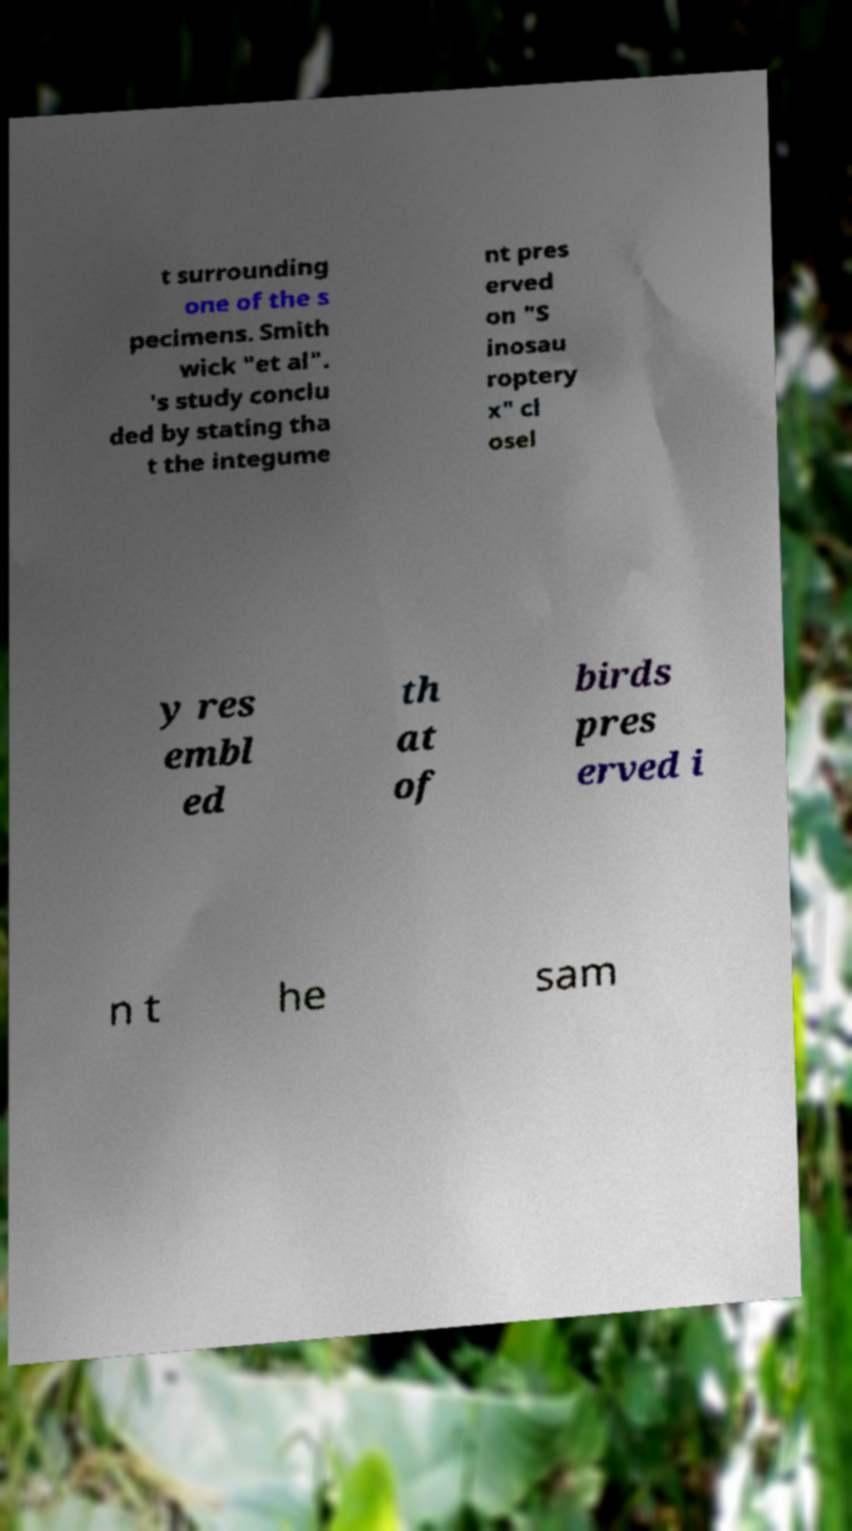Can you read and provide the text displayed in the image?This photo seems to have some interesting text. Can you extract and type it out for me? t surrounding one of the s pecimens. Smith wick "et al". 's study conclu ded by stating tha t the integume nt pres erved on "S inosau roptery x" cl osel y res embl ed th at of birds pres erved i n t he sam 